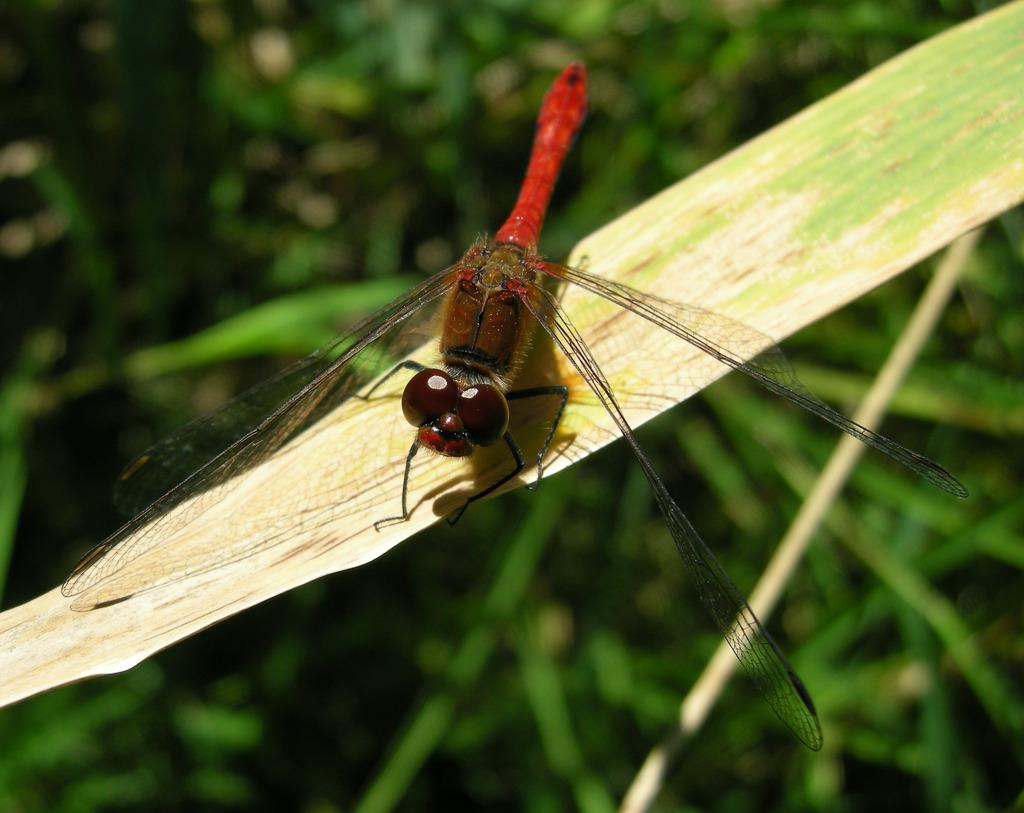What is on the leaf in the image? There is an insect on a leaf in the image. What can be seen in the distance behind the leaf? There are trees visible in the background of the image. How would you describe the appearance of the background? The background appears blurry. What type of fruit is the insect holding in the image? There is no fruit present in the image, and the insect is not holding anything. 